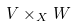<formula> <loc_0><loc_0><loc_500><loc_500>V \times _ { X } W</formula> 